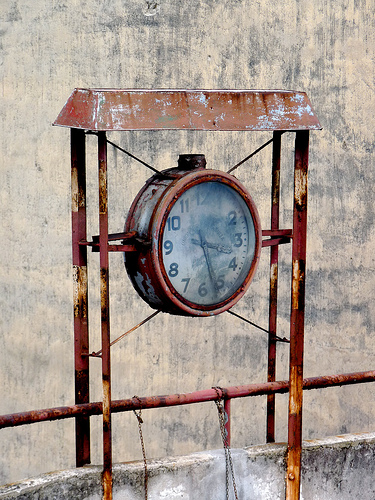What does the setting imply about the location or history of this clock? The setting, with its industrial features and aged appearance, suggests that the clock is likely situated in an older, perhaps neglected, industrial or urban environment. This environment, coupled with the clock's design and condition, hints at a long history likely tied to a once bustling but now quieter area. 